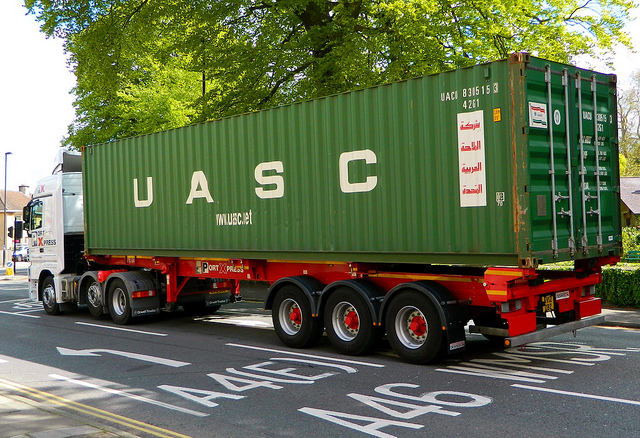Please transcribe the text in this image. 8315153 4281 U A S C NMSR A46 A4CE XPRESS XPRESS 